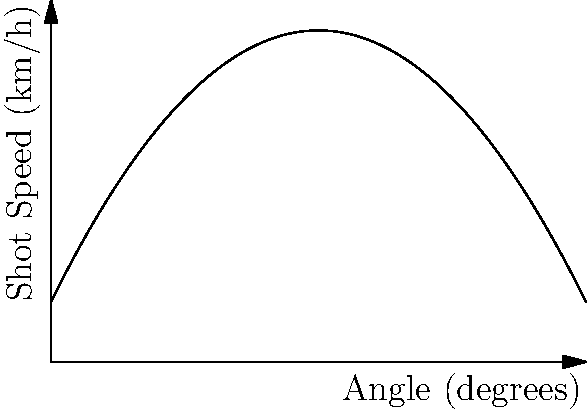As the coach of the school's hockey team, you're working on improving your players' shot power. The graph shows the relationship between the angle of a hockey stick and the resulting shot speed. Based on this information, at what angle should players hold their sticks to achieve the maximum shot speed? To find the optimal angle for maximum shot power, we need to analyze the given graph:

1. The graph shows a parabolic curve, which is typical for quadratic functions.
2. The peak of the parabola represents the maximum shot speed.
3. To find the angle corresponding to this maximum, we need to locate the vertex of the parabola.
4. The vertex is clearly marked on the graph with a dot and labeled "Maximum".
5. Drawing a vertical line from the vertex to the x-axis gives us the optimal angle.
6. Reading from the x-axis, we can see that this line intersects at 30 degrees.

Therefore, the optimal angle for players to hold their hockey sticks to achieve maximum shot speed is 30 degrees.

This information can be used to coach players on proper stick handling technique for powerful shots. Remember, while power is important, accuracy and quick release are also crucial in hockey, so players should practice at various angles as well.
Answer: 30 degrees 